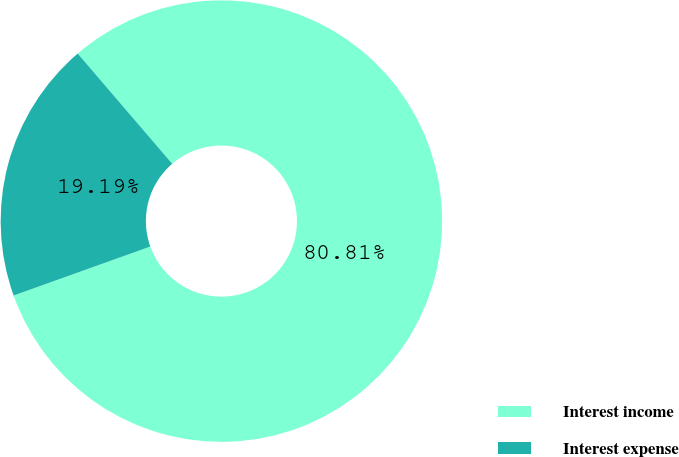Convert chart. <chart><loc_0><loc_0><loc_500><loc_500><pie_chart><fcel>Interest income<fcel>Interest expense<nl><fcel>80.81%<fcel>19.19%<nl></chart> 